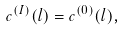Convert formula to latex. <formula><loc_0><loc_0><loc_500><loc_500>c ^ { ( I ) } ( l ) = c ^ { ( 0 ) } ( l ) ,</formula> 